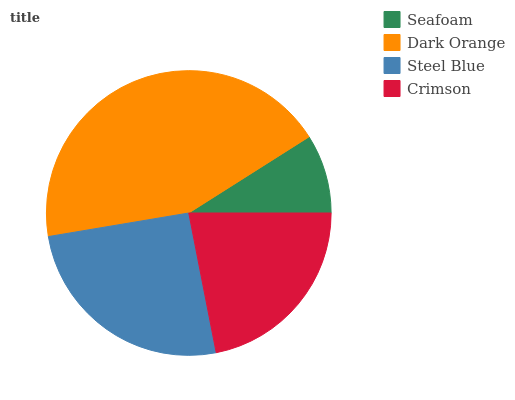Is Seafoam the minimum?
Answer yes or no. Yes. Is Dark Orange the maximum?
Answer yes or no. Yes. Is Steel Blue the minimum?
Answer yes or no. No. Is Steel Blue the maximum?
Answer yes or no. No. Is Dark Orange greater than Steel Blue?
Answer yes or no. Yes. Is Steel Blue less than Dark Orange?
Answer yes or no. Yes. Is Steel Blue greater than Dark Orange?
Answer yes or no. No. Is Dark Orange less than Steel Blue?
Answer yes or no. No. Is Steel Blue the high median?
Answer yes or no. Yes. Is Crimson the low median?
Answer yes or no. Yes. Is Crimson the high median?
Answer yes or no. No. Is Steel Blue the low median?
Answer yes or no. No. 